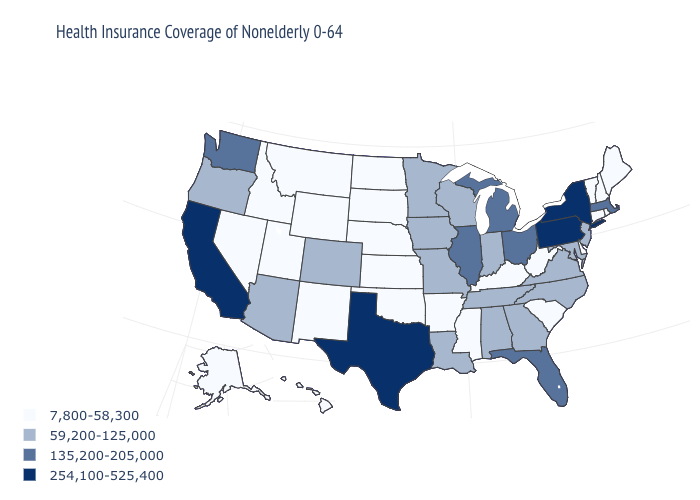Among the states that border New York , does Pennsylvania have the highest value?
Quick response, please. Yes. Is the legend a continuous bar?
Give a very brief answer. No. How many symbols are there in the legend?
Answer briefly. 4. Name the states that have a value in the range 135,200-205,000?
Keep it brief. Florida, Illinois, Massachusetts, Michigan, Ohio, Washington. Which states have the highest value in the USA?
Be succinct. California, New York, Pennsylvania, Texas. What is the value of New Mexico?
Give a very brief answer. 7,800-58,300. Among the states that border Oregon , does California have the highest value?
Write a very short answer. Yes. Does Louisiana have the highest value in the USA?
Short answer required. No. What is the value of Alaska?
Quick response, please. 7,800-58,300. Which states have the highest value in the USA?
Concise answer only. California, New York, Pennsylvania, Texas. Name the states that have a value in the range 59,200-125,000?
Answer briefly. Alabama, Arizona, Colorado, Georgia, Indiana, Iowa, Louisiana, Maryland, Minnesota, Missouri, New Jersey, North Carolina, Oregon, Tennessee, Virginia, Wisconsin. What is the lowest value in states that border Missouri?
Be succinct. 7,800-58,300. Name the states that have a value in the range 254,100-525,400?
Keep it brief. California, New York, Pennsylvania, Texas. Which states have the lowest value in the USA?
Short answer required. Alaska, Arkansas, Connecticut, Delaware, Hawaii, Idaho, Kansas, Kentucky, Maine, Mississippi, Montana, Nebraska, Nevada, New Hampshire, New Mexico, North Dakota, Oklahoma, Rhode Island, South Carolina, South Dakota, Utah, Vermont, West Virginia, Wyoming. 